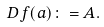<formula> <loc_0><loc_0><loc_500><loc_500>D f ( a ) \colon = A .</formula> 